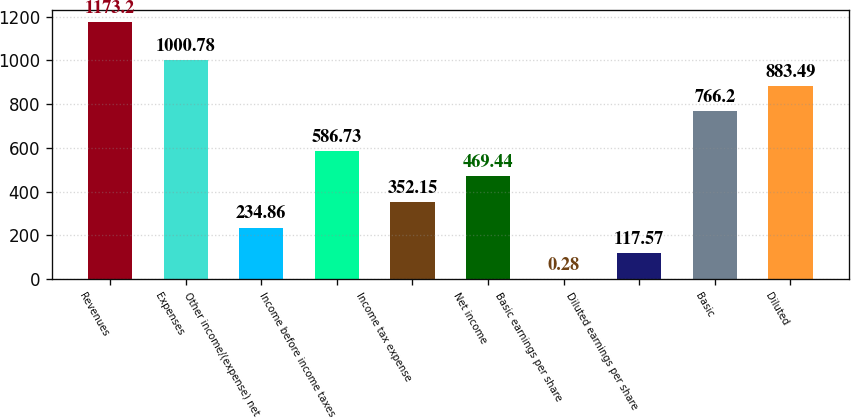Convert chart. <chart><loc_0><loc_0><loc_500><loc_500><bar_chart><fcel>Revenues<fcel>Expenses<fcel>Other income/(expense) net<fcel>Income before income taxes<fcel>Income tax expense<fcel>Net income<fcel>Basic earnings per share<fcel>Diluted earnings per share<fcel>Basic<fcel>Diluted<nl><fcel>1173.2<fcel>1000.78<fcel>234.86<fcel>586.73<fcel>352.15<fcel>469.44<fcel>0.28<fcel>117.57<fcel>766.2<fcel>883.49<nl></chart> 